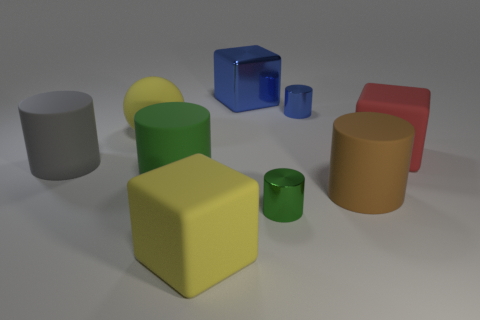What is the green object that is to the left of the big cube that is on the left side of the blue metallic cube made of?
Provide a short and direct response. Rubber. What is the material of the large object that is in front of the large gray rubber object and on the right side of the big blue object?
Give a very brief answer. Rubber. Is the material of the small object that is behind the large gray cylinder the same as the big red block?
Your answer should be compact. No. Is the number of large red rubber objects less than the number of small green rubber blocks?
Your response must be concise. No. There is a small object that is in front of the yellow rubber object behind the yellow rubber block; is there a block to the left of it?
Your response must be concise. Yes. Is the shape of the large yellow thing that is in front of the big gray object the same as  the large red thing?
Keep it short and to the point. Yes. Is the number of shiny cylinders left of the blue metal cylinder greater than the number of large purple metallic balls?
Your answer should be compact. Yes. Do the tiny cylinder that is behind the large gray object and the big shiny thing have the same color?
Offer a terse response. Yes. Is there any other thing that is the same color as the large rubber sphere?
Your answer should be compact. Yes. The cylinder behind the large object that is to the left of the yellow thing left of the yellow matte block is what color?
Make the answer very short. Blue. 